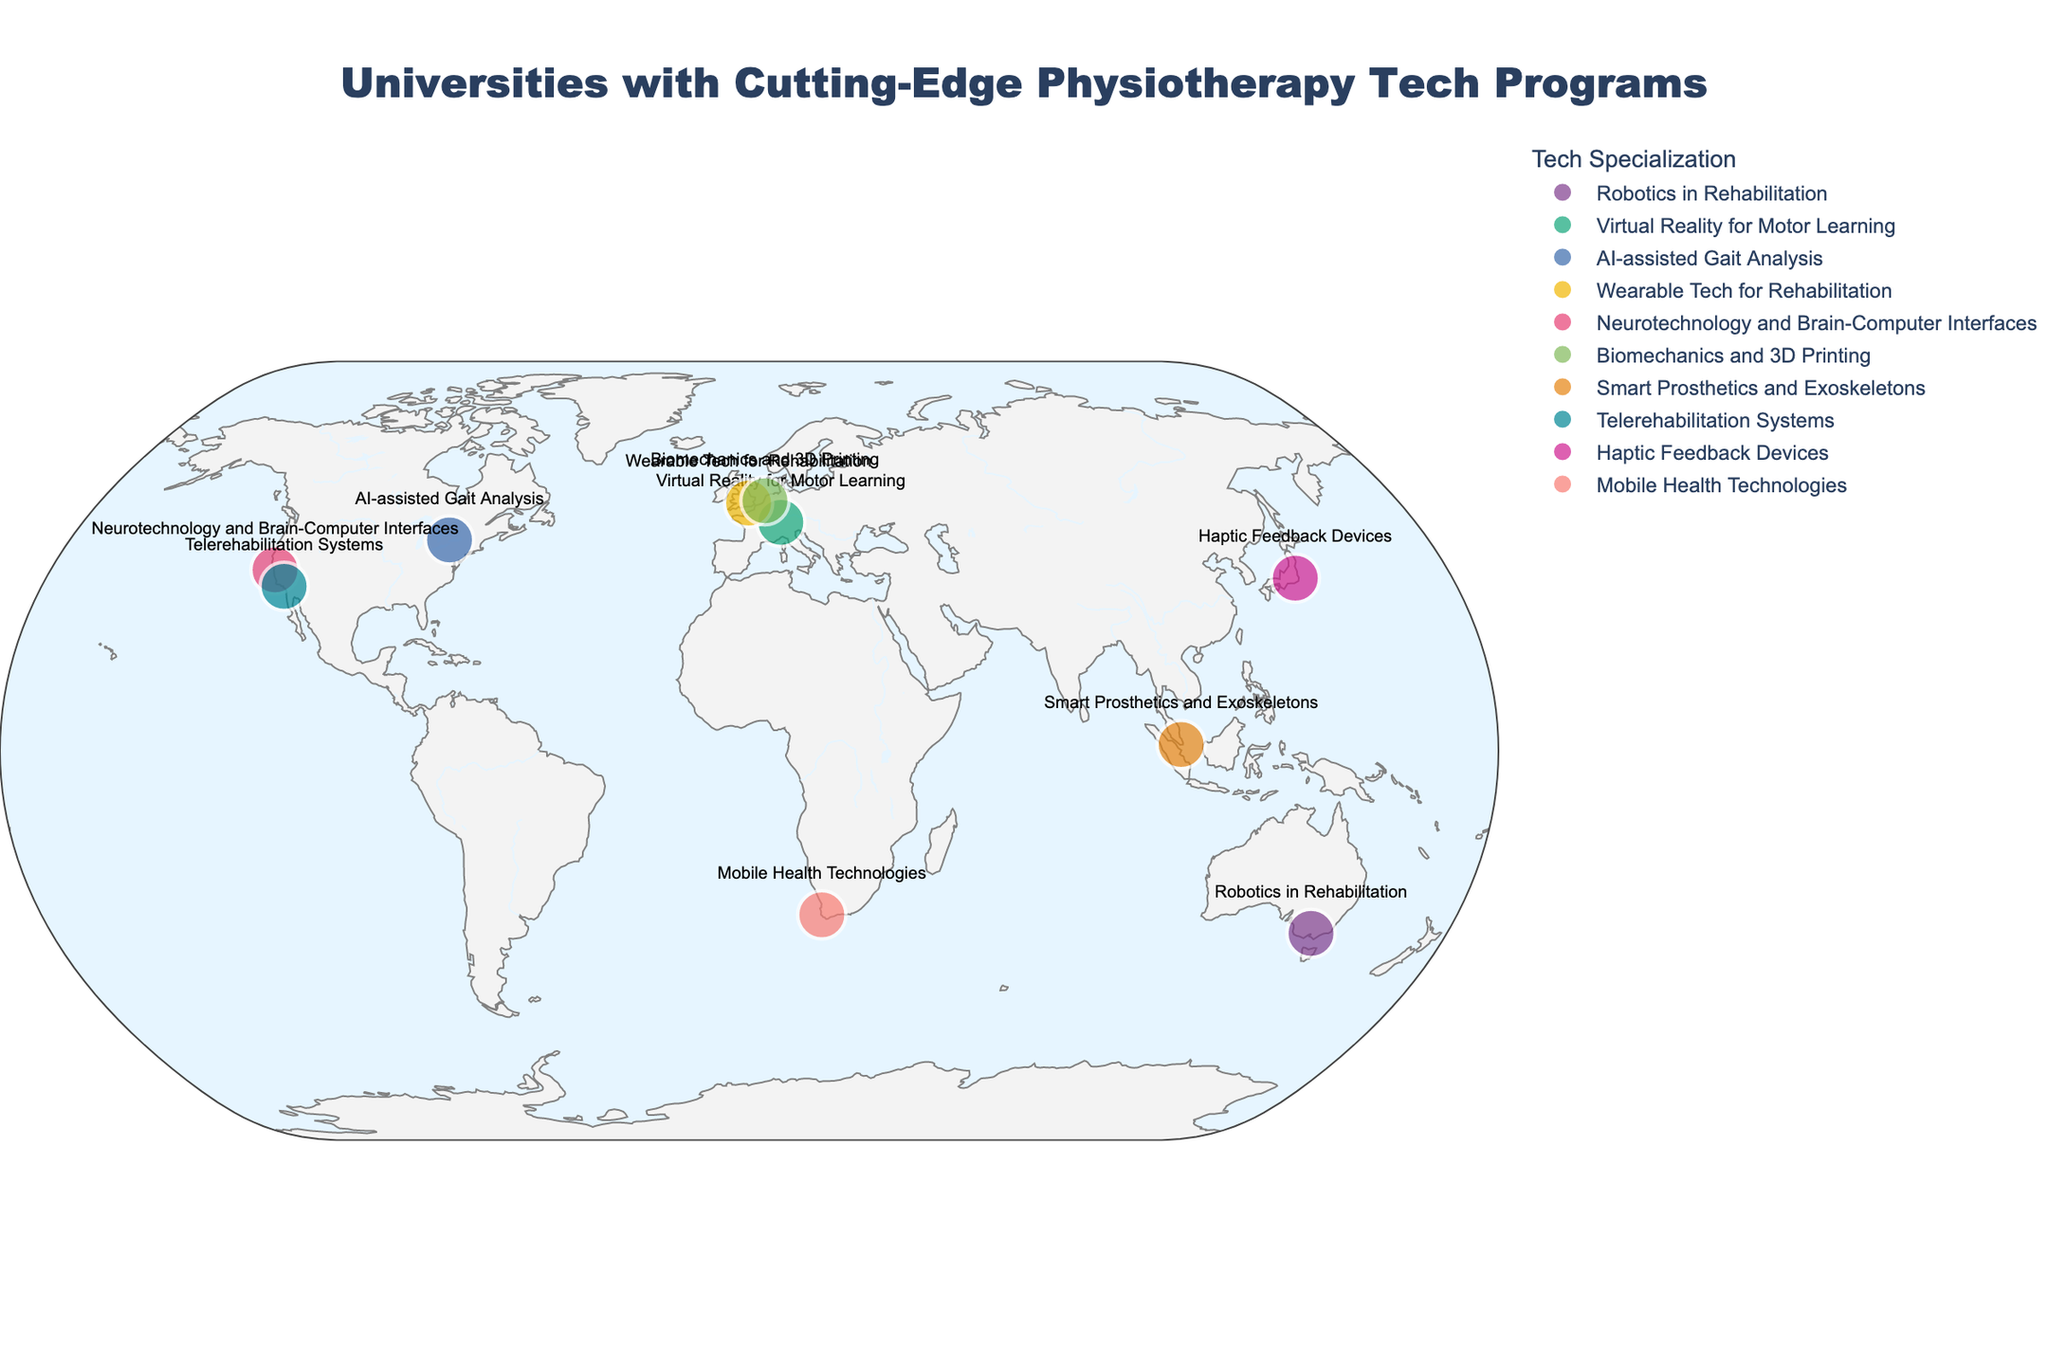How many universities are located in the United States according to the plot? Look for the dots on the map representing universities in the United States. There are two indicated by "Stanford University" and "University of Southern California."
Answer: 2 What is the title of the figure? The title of the figure is provided at the top of the visual map. It reads "Universities with Cutting-Edge Physiotherapy Tech Programs."
Answer: Universities with Cutting-Edge Physiotherapy Tech Programs Which university specializes in Neurotechnology and Brain-Computer Interfaces? By inspecting the hover text on the corresponding data points, Stanford University is indicated as specializing in "Neurotechnology and Brain-Computer Interfaces."
Answer: Stanford University Compare the number of universities in Europe and Asia shown on the plot. Which continent has more universities? By counting the dots in the map for Europe (ETH Zurich, Imperial College London, Delft University of Technology) and Asia (National University of Singapore, University of Tokyo), Europe has three universities while Asia has two.
Answer: Europe Which city has a university that specializes in Haptic Feedback Devices? By checking the tech specialization via the hover text, University of Tokyo specializes in Haptic Feedback Devices. Therefore, the city is Tokyo.
Answer: Tokyo What's the tech specialization of the University in Cape Town? Look for the corresponding data point in Cape Town on the map. The specialization is stated in the hover text as "Mobile Health Technologies."
Answer: Mobile Health Technologies Are there any universities offering "Wearable Tech for Rehabilitation" located in the Southern Hemisphere? By reviewing both the tech specialization and their latitude coordinates, only the universities in Australia (University of Melbourne) and South Africa (University of Cape Town) are in the Southern Hemisphere. Neither specializes in "Wearable Tech for Rehabilitation."
Answer: No How many universities are marked with the same color on the map? Since colors represent different tech specializations, each university has a unique color, making the number the same as the total universities plotted.
Answer: 10 Which university is located at the highest latitude? The highest latitude corresponds to the northernmost point. By comparing latitudes, Delft University of Technology in Delft, Netherlands (52.0022) has the highest latitude.
Answer: Delft University of Technology 